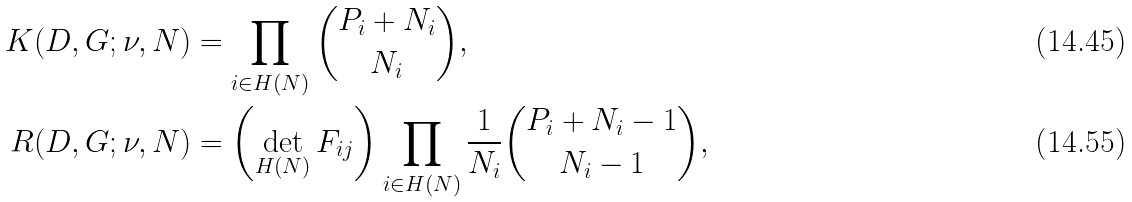Convert formula to latex. <formula><loc_0><loc_0><loc_500><loc_500>K ( D , G ; \nu , N ) & = \prod _ { i \in H ( N ) } \binom { P _ { i } + N _ { i } } { N _ { i } } , \\ R ( D , G ; \nu , N ) & = \left ( \det _ { H ( N ) } F _ { i j } \right ) \prod _ { i \in H ( N ) } \frac { 1 } { N _ { i } } \binom { P _ { i } + N _ { i } - 1 } { N _ { i } - 1 } ,</formula> 